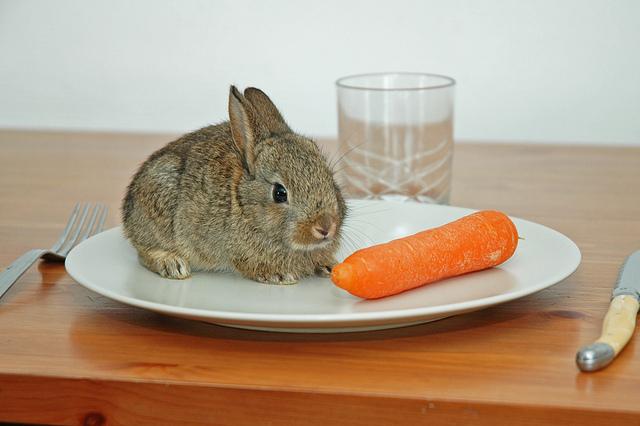Is this an acceptable meal?
Write a very short answer. No. What is the bunny about to eat?
Give a very brief answer. Carrot. What type of animal is pictured?
Concise answer only. Rabbit. 